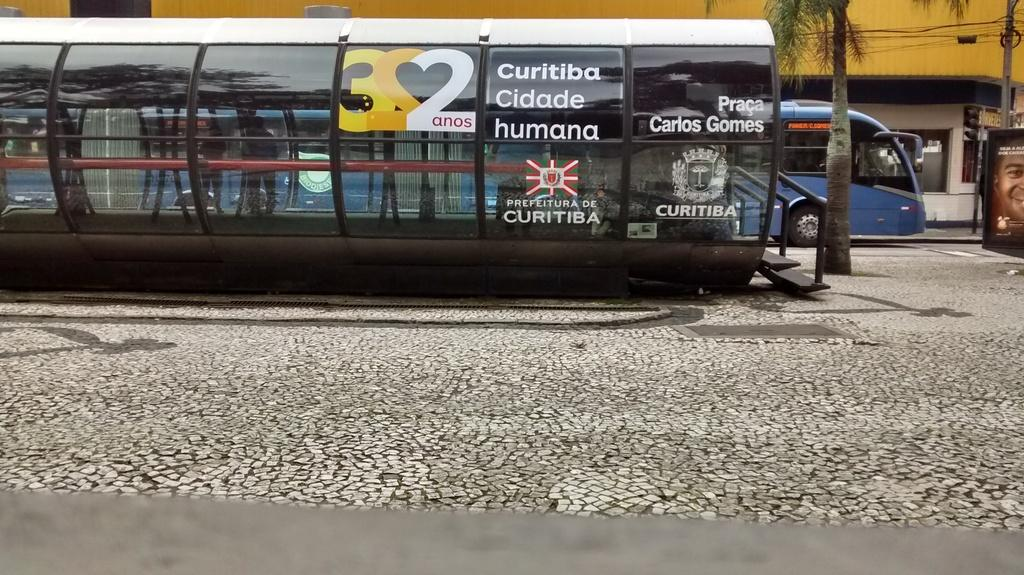<image>
Describe the image concisely. A glass enclosure contains the text "curitiba" on the outside. 